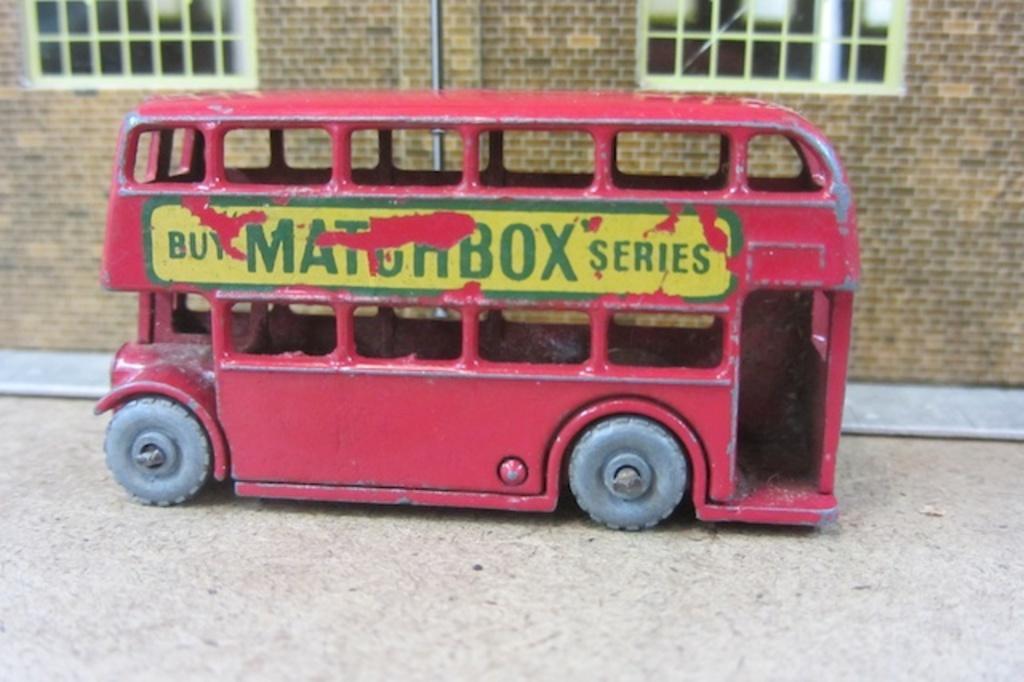Please provide a concise description of this image. In this image there is a red toy car. In the background there is building. 